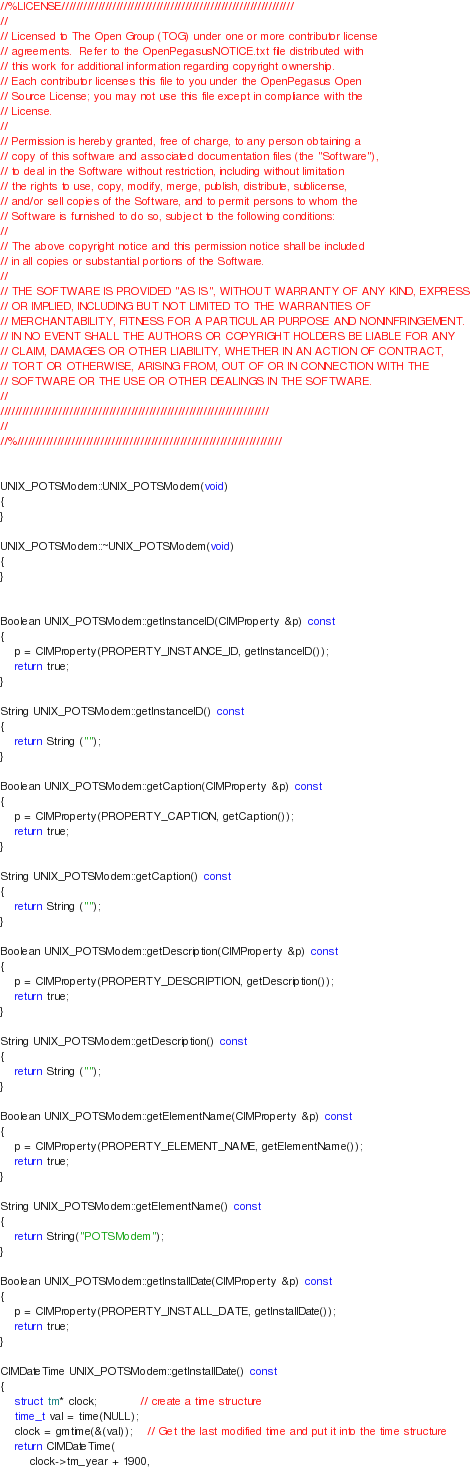Convert code to text. <code><loc_0><loc_0><loc_500><loc_500><_C++_>//%LICENSE////////////////////////////////////////////////////////////////
//
// Licensed to The Open Group (TOG) under one or more contributor license
// agreements.  Refer to the OpenPegasusNOTICE.txt file distributed with
// this work for additional information regarding copyright ownership.
// Each contributor licenses this file to you under the OpenPegasus Open
// Source License; you may not use this file except in compliance with the
// License.
//
// Permission is hereby granted, free of charge, to any person obtaining a
// copy of this software and associated documentation files (the "Software"),
// to deal in the Software without restriction, including without limitation
// the rights to use, copy, modify, merge, publish, distribute, sublicense,
// and/or sell copies of the Software, and to permit persons to whom the
// Software is furnished to do so, subject to the following conditions:
//
// The above copyright notice and this permission notice shall be included
// in all copies or substantial portions of the Software.
//
// THE SOFTWARE IS PROVIDED "AS IS", WITHOUT WARRANTY OF ANY KIND, EXPRESS
// OR IMPLIED, INCLUDING BUT NOT LIMITED TO THE WARRANTIES OF
// MERCHANTABILITY, FITNESS FOR A PARTICULAR PURPOSE AND NONINFRINGEMENT.
// IN NO EVENT SHALL THE AUTHORS OR COPYRIGHT HOLDERS BE LIABLE FOR ANY
// CLAIM, DAMAGES OR OTHER LIABILITY, WHETHER IN AN ACTION OF CONTRACT,
// TORT OR OTHERWISE, ARISING FROM, OUT OF OR IN CONNECTION WITH THE
// SOFTWARE OR THE USE OR OTHER DEALINGS IN THE SOFTWARE.
//
//////////////////////////////////////////////////////////////////////////
//
//%/////////////////////////////////////////////////////////////////////////


UNIX_POTSModem::UNIX_POTSModem(void)
{
}

UNIX_POTSModem::~UNIX_POTSModem(void)
{
}


Boolean UNIX_POTSModem::getInstanceID(CIMProperty &p) const
{
	p = CIMProperty(PROPERTY_INSTANCE_ID, getInstanceID());
	return true;
}

String UNIX_POTSModem::getInstanceID() const
{
	return String ("");
}

Boolean UNIX_POTSModem::getCaption(CIMProperty &p) const
{
	p = CIMProperty(PROPERTY_CAPTION, getCaption());
	return true;
}

String UNIX_POTSModem::getCaption() const
{
	return String ("");
}

Boolean UNIX_POTSModem::getDescription(CIMProperty &p) const
{
	p = CIMProperty(PROPERTY_DESCRIPTION, getDescription());
	return true;
}

String UNIX_POTSModem::getDescription() const
{
	return String ("");
}

Boolean UNIX_POTSModem::getElementName(CIMProperty &p) const
{
	p = CIMProperty(PROPERTY_ELEMENT_NAME, getElementName());
	return true;
}

String UNIX_POTSModem::getElementName() const
{
	return String("POTSModem");
}

Boolean UNIX_POTSModem::getInstallDate(CIMProperty &p) const
{
	p = CIMProperty(PROPERTY_INSTALL_DATE, getInstallDate());
	return true;
}

CIMDateTime UNIX_POTSModem::getInstallDate() const
{
	struct tm* clock;			// create a time structure
	time_t val = time(NULL);
	clock = gmtime(&(val));	// Get the last modified time and put it into the time structure
	return CIMDateTime(
		clock->tm_year + 1900,</code> 